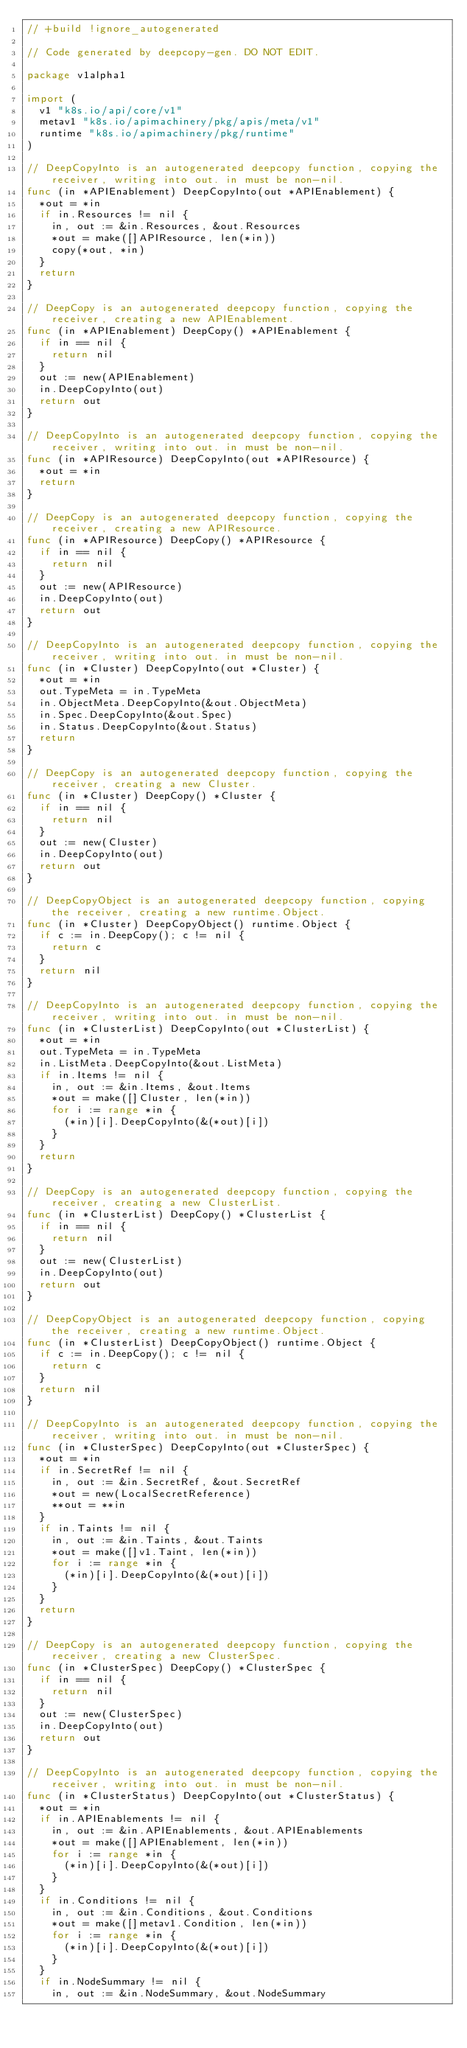Convert code to text. <code><loc_0><loc_0><loc_500><loc_500><_Go_>// +build !ignore_autogenerated

// Code generated by deepcopy-gen. DO NOT EDIT.

package v1alpha1

import (
	v1 "k8s.io/api/core/v1"
	metav1 "k8s.io/apimachinery/pkg/apis/meta/v1"
	runtime "k8s.io/apimachinery/pkg/runtime"
)

// DeepCopyInto is an autogenerated deepcopy function, copying the receiver, writing into out. in must be non-nil.
func (in *APIEnablement) DeepCopyInto(out *APIEnablement) {
	*out = *in
	if in.Resources != nil {
		in, out := &in.Resources, &out.Resources
		*out = make([]APIResource, len(*in))
		copy(*out, *in)
	}
	return
}

// DeepCopy is an autogenerated deepcopy function, copying the receiver, creating a new APIEnablement.
func (in *APIEnablement) DeepCopy() *APIEnablement {
	if in == nil {
		return nil
	}
	out := new(APIEnablement)
	in.DeepCopyInto(out)
	return out
}

// DeepCopyInto is an autogenerated deepcopy function, copying the receiver, writing into out. in must be non-nil.
func (in *APIResource) DeepCopyInto(out *APIResource) {
	*out = *in
	return
}

// DeepCopy is an autogenerated deepcopy function, copying the receiver, creating a new APIResource.
func (in *APIResource) DeepCopy() *APIResource {
	if in == nil {
		return nil
	}
	out := new(APIResource)
	in.DeepCopyInto(out)
	return out
}

// DeepCopyInto is an autogenerated deepcopy function, copying the receiver, writing into out. in must be non-nil.
func (in *Cluster) DeepCopyInto(out *Cluster) {
	*out = *in
	out.TypeMeta = in.TypeMeta
	in.ObjectMeta.DeepCopyInto(&out.ObjectMeta)
	in.Spec.DeepCopyInto(&out.Spec)
	in.Status.DeepCopyInto(&out.Status)
	return
}

// DeepCopy is an autogenerated deepcopy function, copying the receiver, creating a new Cluster.
func (in *Cluster) DeepCopy() *Cluster {
	if in == nil {
		return nil
	}
	out := new(Cluster)
	in.DeepCopyInto(out)
	return out
}

// DeepCopyObject is an autogenerated deepcopy function, copying the receiver, creating a new runtime.Object.
func (in *Cluster) DeepCopyObject() runtime.Object {
	if c := in.DeepCopy(); c != nil {
		return c
	}
	return nil
}

// DeepCopyInto is an autogenerated deepcopy function, copying the receiver, writing into out. in must be non-nil.
func (in *ClusterList) DeepCopyInto(out *ClusterList) {
	*out = *in
	out.TypeMeta = in.TypeMeta
	in.ListMeta.DeepCopyInto(&out.ListMeta)
	if in.Items != nil {
		in, out := &in.Items, &out.Items
		*out = make([]Cluster, len(*in))
		for i := range *in {
			(*in)[i].DeepCopyInto(&(*out)[i])
		}
	}
	return
}

// DeepCopy is an autogenerated deepcopy function, copying the receiver, creating a new ClusterList.
func (in *ClusterList) DeepCopy() *ClusterList {
	if in == nil {
		return nil
	}
	out := new(ClusterList)
	in.DeepCopyInto(out)
	return out
}

// DeepCopyObject is an autogenerated deepcopy function, copying the receiver, creating a new runtime.Object.
func (in *ClusterList) DeepCopyObject() runtime.Object {
	if c := in.DeepCopy(); c != nil {
		return c
	}
	return nil
}

// DeepCopyInto is an autogenerated deepcopy function, copying the receiver, writing into out. in must be non-nil.
func (in *ClusterSpec) DeepCopyInto(out *ClusterSpec) {
	*out = *in
	if in.SecretRef != nil {
		in, out := &in.SecretRef, &out.SecretRef
		*out = new(LocalSecretReference)
		**out = **in
	}
	if in.Taints != nil {
		in, out := &in.Taints, &out.Taints
		*out = make([]v1.Taint, len(*in))
		for i := range *in {
			(*in)[i].DeepCopyInto(&(*out)[i])
		}
	}
	return
}

// DeepCopy is an autogenerated deepcopy function, copying the receiver, creating a new ClusterSpec.
func (in *ClusterSpec) DeepCopy() *ClusterSpec {
	if in == nil {
		return nil
	}
	out := new(ClusterSpec)
	in.DeepCopyInto(out)
	return out
}

// DeepCopyInto is an autogenerated deepcopy function, copying the receiver, writing into out. in must be non-nil.
func (in *ClusterStatus) DeepCopyInto(out *ClusterStatus) {
	*out = *in
	if in.APIEnablements != nil {
		in, out := &in.APIEnablements, &out.APIEnablements
		*out = make([]APIEnablement, len(*in))
		for i := range *in {
			(*in)[i].DeepCopyInto(&(*out)[i])
		}
	}
	if in.Conditions != nil {
		in, out := &in.Conditions, &out.Conditions
		*out = make([]metav1.Condition, len(*in))
		for i := range *in {
			(*in)[i].DeepCopyInto(&(*out)[i])
		}
	}
	if in.NodeSummary != nil {
		in, out := &in.NodeSummary, &out.NodeSummary</code> 